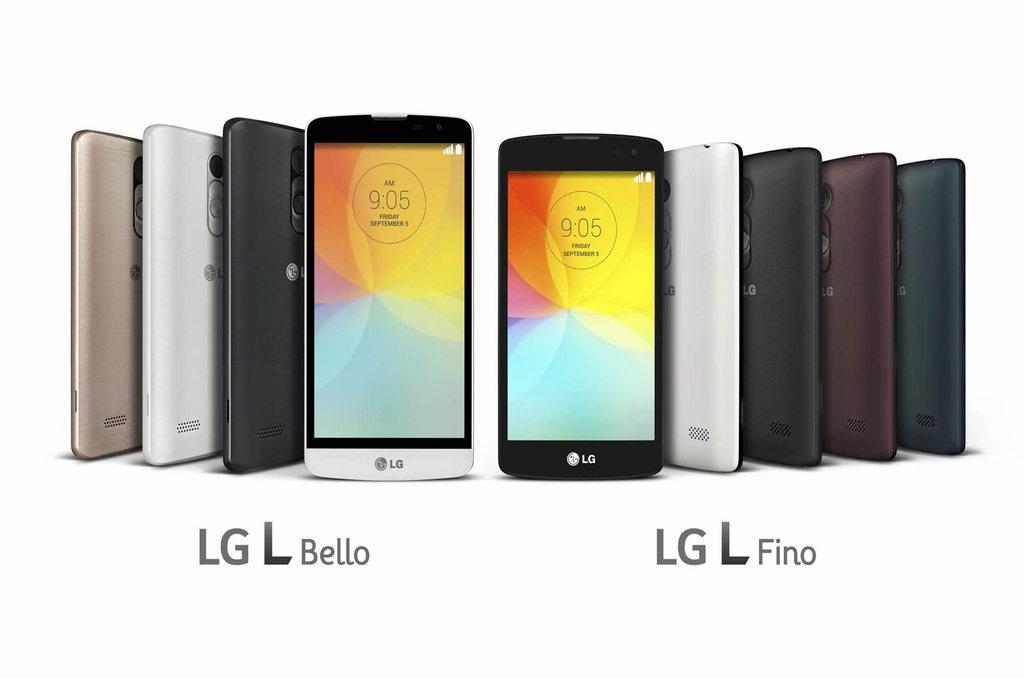<image>
Give a short and clear explanation of the subsequent image. A selection of 9 LG phones standing upright against a white background. 